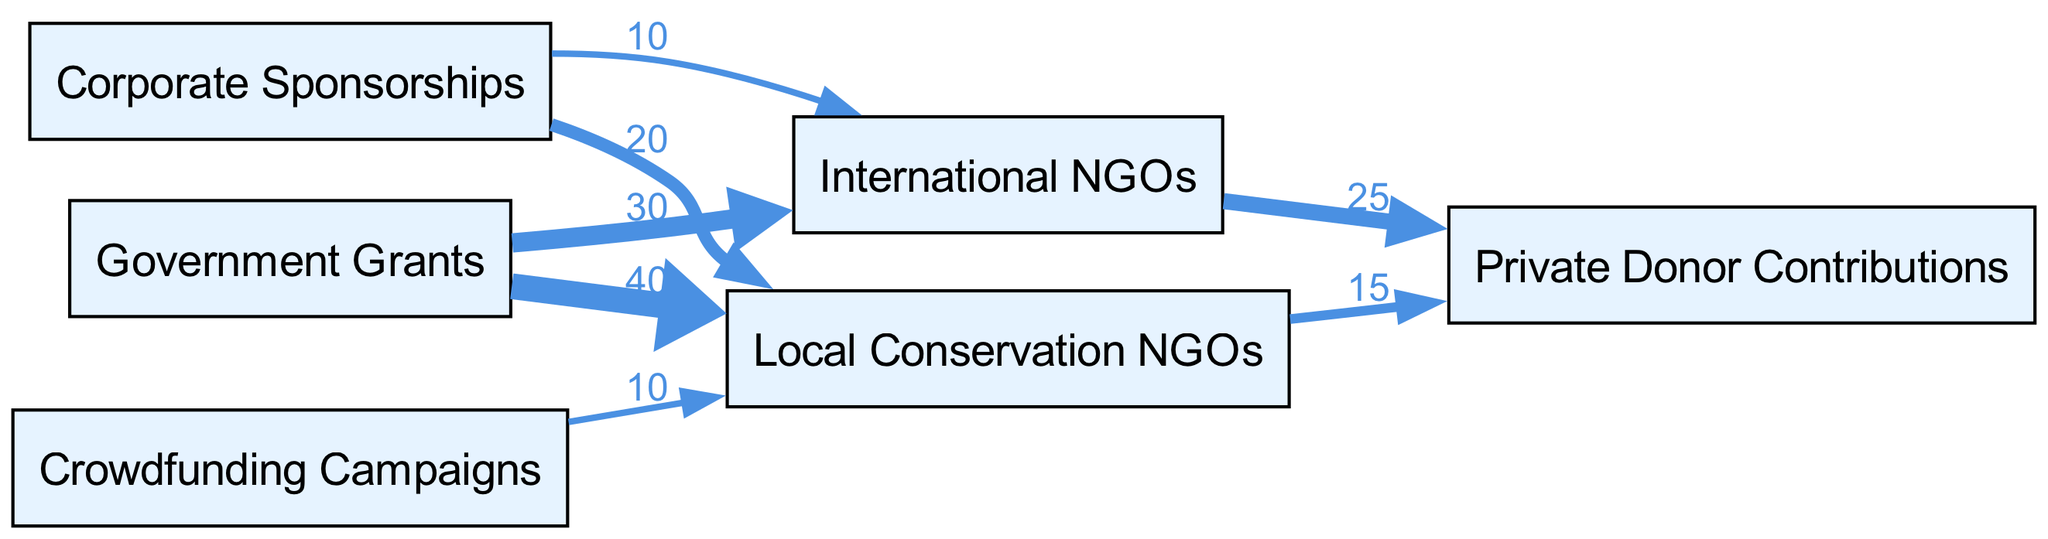What are the total contributions from Government Grants? To find the total contributions from the "Government Grants" node, I need to sum the values of all the links originating from this node. From the diagram, "Government Grants" contributes 40 to "Local Conservation NGOs" and 30 to "International NGOs", totaling 40 + 30 = 70.
Answer: 70 Which node receives the largest contribution from Corporate Sponsorships? To determine which node receives the largest contribution from "Corporate Sponsorships", I look at the links starting from this node. It directs 20 to "Local Conservation NGOs" and 10 to "International NGOs". The larger of these two contributions is 20, which goes to "Local Conservation NGOs".
Answer: Local Conservation NGOs How many nodes are present in the diagram? The total number of nodes in the diagram can be obtained from the "nodes" section of the data. It lists 6 distinct nodes: Government Grants, International NGOs, Local Conservation NGOs, Private Donor Contributions, Corporate Sponsorships, and Crowdfunding Campaigns. Therefore, the total count is 6.
Answer: 6 What is the flow value from Local Conservation NGOs to Private Donor Contributions? I check the link that goes from "Local Conservation NGOs" to "Private Donor Contributions". According to the data, this link has a value of 15.
Answer: 15 How does total funding from International NGOs compare to funding through Crowdfunding Campaigns? I analyze the contributions from "International NGOs", which include 25 towards "Private Donor Contributions" and 10 towards "Corporate Sponsorships", totaling 25 + 10 = 35. "Crowdfunding Campaigns" contributes a total of 10 to "Local Conservation NGOs". Therefore, 35 (International NGOs) is greater than 10 (Crowdfunding Campaigns).
Answer: Greater What percentage of contributions to Local Conservation NGOs comes from Government Grants? First, I find the total contributions to "Local Conservation NGOs". It receives 40 from "Government Grants", 10 from "Crowdfunding Campaigns", and 20 from "Corporate Sponsorships", totaling 70. The contribution from "Government Grants" is 40. To find the percentage, I calculate (40 / 70) * 100 = 57.14%.
Answer: 57.14% Which source has dual funding paths in the diagram? To identify sources with dual funding paths, I review the links. "Corporate Sponsorships" directs funds to both "Local Conservation NGOs" (20) and "International NGOs" (10), hence it has dual pathways.
Answer: Corporate Sponsorships What is the value of the smallest contribution to any node? I examine all values in the links. The smallest value noted is 10, which is contributed by "Crowdfunding Campaigns" to "Local Conservation NGOs".
Answer: 10 